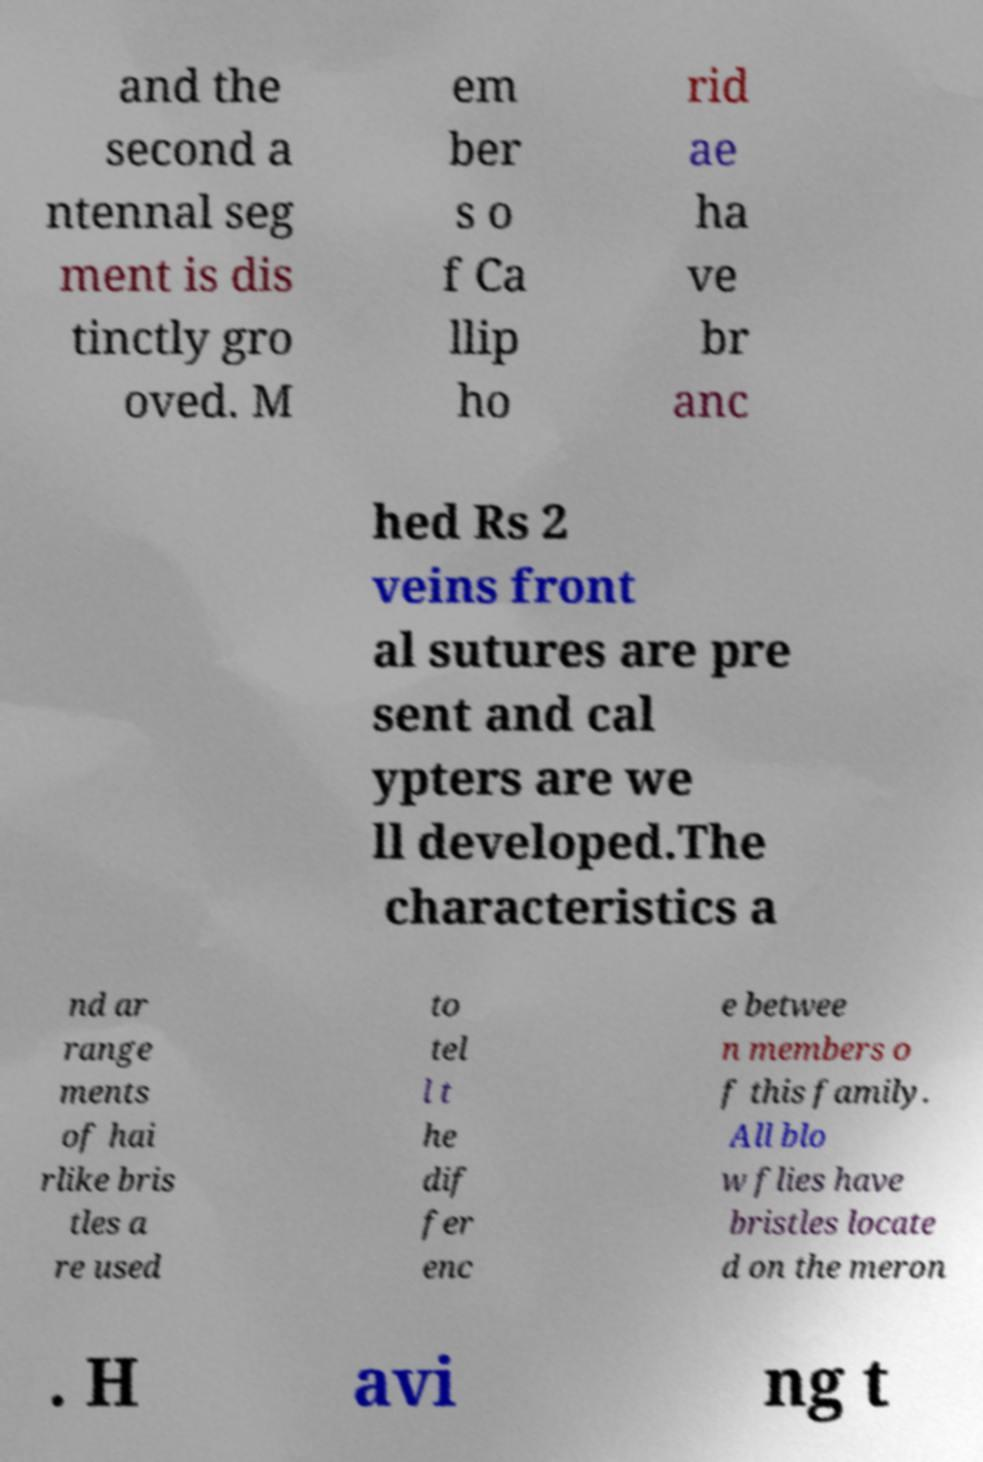Please read and relay the text visible in this image. What does it say? and the second a ntennal seg ment is dis tinctly gro oved. M em ber s o f Ca llip ho rid ae ha ve br anc hed Rs 2 veins front al sutures are pre sent and cal ypters are we ll developed.The characteristics a nd ar range ments of hai rlike bris tles a re used to tel l t he dif fer enc e betwee n members o f this family. All blo w flies have bristles locate d on the meron . H avi ng t 